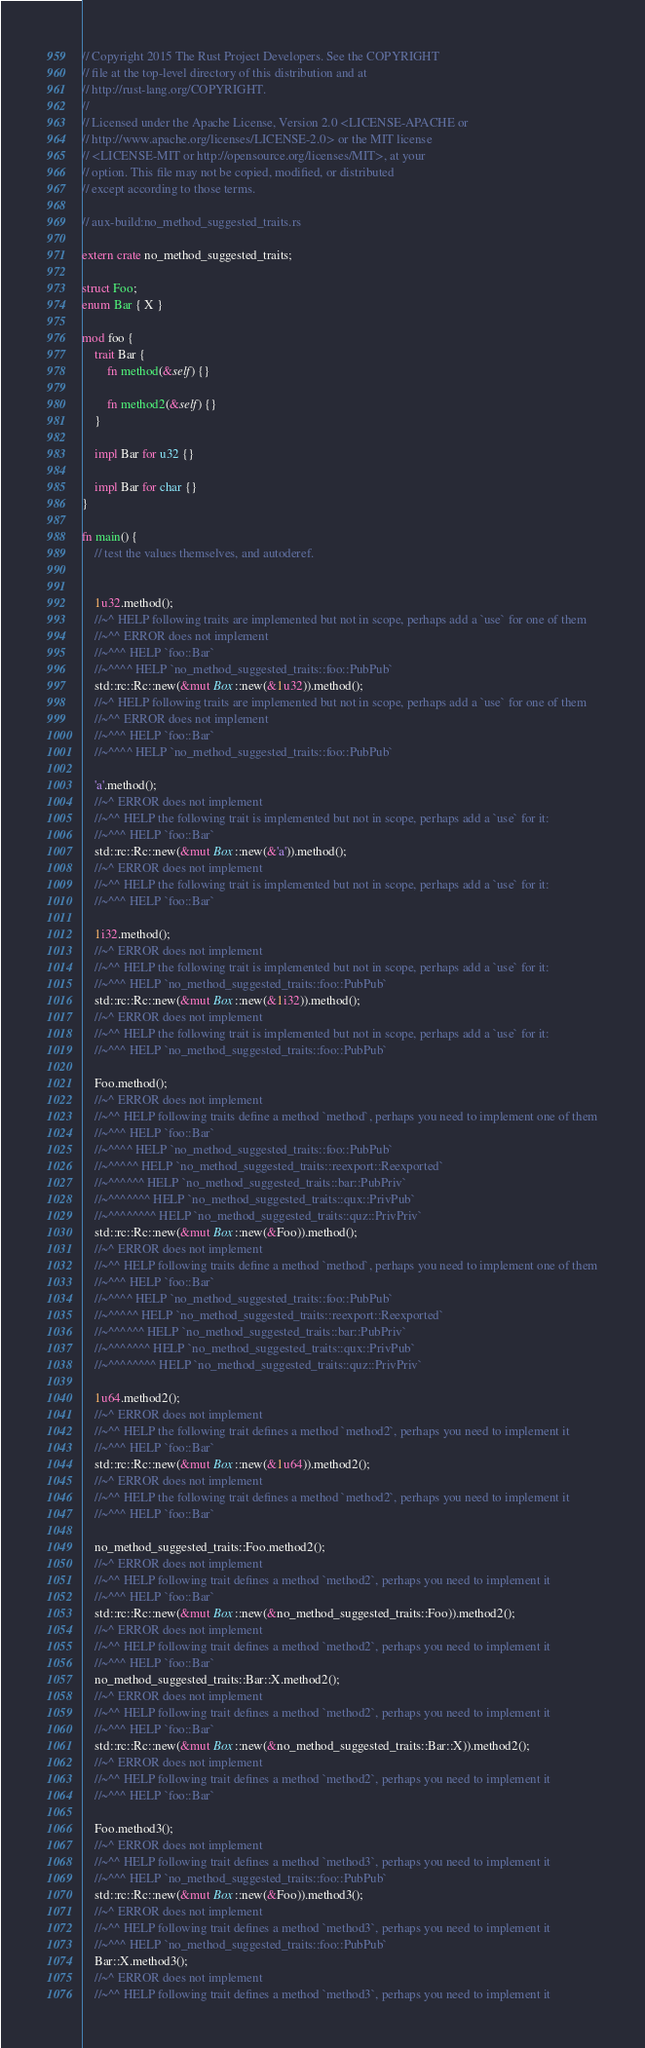<code> <loc_0><loc_0><loc_500><loc_500><_Rust_>// Copyright 2015 The Rust Project Developers. See the COPYRIGHT
// file at the top-level directory of this distribution and at
// http://rust-lang.org/COPYRIGHT.
//
// Licensed under the Apache License, Version 2.0 <LICENSE-APACHE or
// http://www.apache.org/licenses/LICENSE-2.0> or the MIT license
// <LICENSE-MIT or http://opensource.org/licenses/MIT>, at your
// option. This file may not be copied, modified, or distributed
// except according to those terms.

// aux-build:no_method_suggested_traits.rs

extern crate no_method_suggested_traits;

struct Foo;
enum Bar { X }

mod foo {
    trait Bar {
        fn method(&self) {}

        fn method2(&self) {}
    }

    impl Bar for u32 {}

    impl Bar for char {}
}

fn main() {
    // test the values themselves, and autoderef.


    1u32.method();
    //~^ HELP following traits are implemented but not in scope, perhaps add a `use` for one of them
    //~^^ ERROR does not implement
    //~^^^ HELP `foo::Bar`
    //~^^^^ HELP `no_method_suggested_traits::foo::PubPub`
    std::rc::Rc::new(&mut Box::new(&1u32)).method();
    //~^ HELP following traits are implemented but not in scope, perhaps add a `use` for one of them
    //~^^ ERROR does not implement
    //~^^^ HELP `foo::Bar`
    //~^^^^ HELP `no_method_suggested_traits::foo::PubPub`

    'a'.method();
    //~^ ERROR does not implement
    //~^^ HELP the following trait is implemented but not in scope, perhaps add a `use` for it:
    //~^^^ HELP `foo::Bar`
    std::rc::Rc::new(&mut Box::new(&'a')).method();
    //~^ ERROR does not implement
    //~^^ HELP the following trait is implemented but not in scope, perhaps add a `use` for it:
    //~^^^ HELP `foo::Bar`

    1i32.method();
    //~^ ERROR does not implement
    //~^^ HELP the following trait is implemented but not in scope, perhaps add a `use` for it:
    //~^^^ HELP `no_method_suggested_traits::foo::PubPub`
    std::rc::Rc::new(&mut Box::new(&1i32)).method();
    //~^ ERROR does not implement
    //~^^ HELP the following trait is implemented but not in scope, perhaps add a `use` for it:
    //~^^^ HELP `no_method_suggested_traits::foo::PubPub`

    Foo.method();
    //~^ ERROR does not implement
    //~^^ HELP following traits define a method `method`, perhaps you need to implement one of them
    //~^^^ HELP `foo::Bar`
    //~^^^^ HELP `no_method_suggested_traits::foo::PubPub`
    //~^^^^^ HELP `no_method_suggested_traits::reexport::Reexported`
    //~^^^^^^ HELP `no_method_suggested_traits::bar::PubPriv`
    //~^^^^^^^ HELP `no_method_suggested_traits::qux::PrivPub`
    //~^^^^^^^^ HELP `no_method_suggested_traits::quz::PrivPriv`
    std::rc::Rc::new(&mut Box::new(&Foo)).method();
    //~^ ERROR does not implement
    //~^^ HELP following traits define a method `method`, perhaps you need to implement one of them
    //~^^^ HELP `foo::Bar`
    //~^^^^ HELP `no_method_suggested_traits::foo::PubPub`
    //~^^^^^ HELP `no_method_suggested_traits::reexport::Reexported`
    //~^^^^^^ HELP `no_method_suggested_traits::bar::PubPriv`
    //~^^^^^^^ HELP `no_method_suggested_traits::qux::PrivPub`
    //~^^^^^^^^ HELP `no_method_suggested_traits::quz::PrivPriv`

    1u64.method2();
    //~^ ERROR does not implement
    //~^^ HELP the following trait defines a method `method2`, perhaps you need to implement it
    //~^^^ HELP `foo::Bar`
    std::rc::Rc::new(&mut Box::new(&1u64)).method2();
    //~^ ERROR does not implement
    //~^^ HELP the following trait defines a method `method2`, perhaps you need to implement it
    //~^^^ HELP `foo::Bar`

    no_method_suggested_traits::Foo.method2();
    //~^ ERROR does not implement
    //~^^ HELP following trait defines a method `method2`, perhaps you need to implement it
    //~^^^ HELP `foo::Bar`
    std::rc::Rc::new(&mut Box::new(&no_method_suggested_traits::Foo)).method2();
    //~^ ERROR does not implement
    //~^^ HELP following trait defines a method `method2`, perhaps you need to implement it
    //~^^^ HELP `foo::Bar`
    no_method_suggested_traits::Bar::X.method2();
    //~^ ERROR does not implement
    //~^^ HELP following trait defines a method `method2`, perhaps you need to implement it
    //~^^^ HELP `foo::Bar`
    std::rc::Rc::new(&mut Box::new(&no_method_suggested_traits::Bar::X)).method2();
    //~^ ERROR does not implement
    //~^^ HELP following trait defines a method `method2`, perhaps you need to implement it
    //~^^^ HELP `foo::Bar`

    Foo.method3();
    //~^ ERROR does not implement
    //~^^ HELP following trait defines a method `method3`, perhaps you need to implement it
    //~^^^ HELP `no_method_suggested_traits::foo::PubPub`
    std::rc::Rc::new(&mut Box::new(&Foo)).method3();
    //~^ ERROR does not implement
    //~^^ HELP following trait defines a method `method3`, perhaps you need to implement it
    //~^^^ HELP `no_method_suggested_traits::foo::PubPub`
    Bar::X.method3();
    //~^ ERROR does not implement
    //~^^ HELP following trait defines a method `method3`, perhaps you need to implement it</code> 